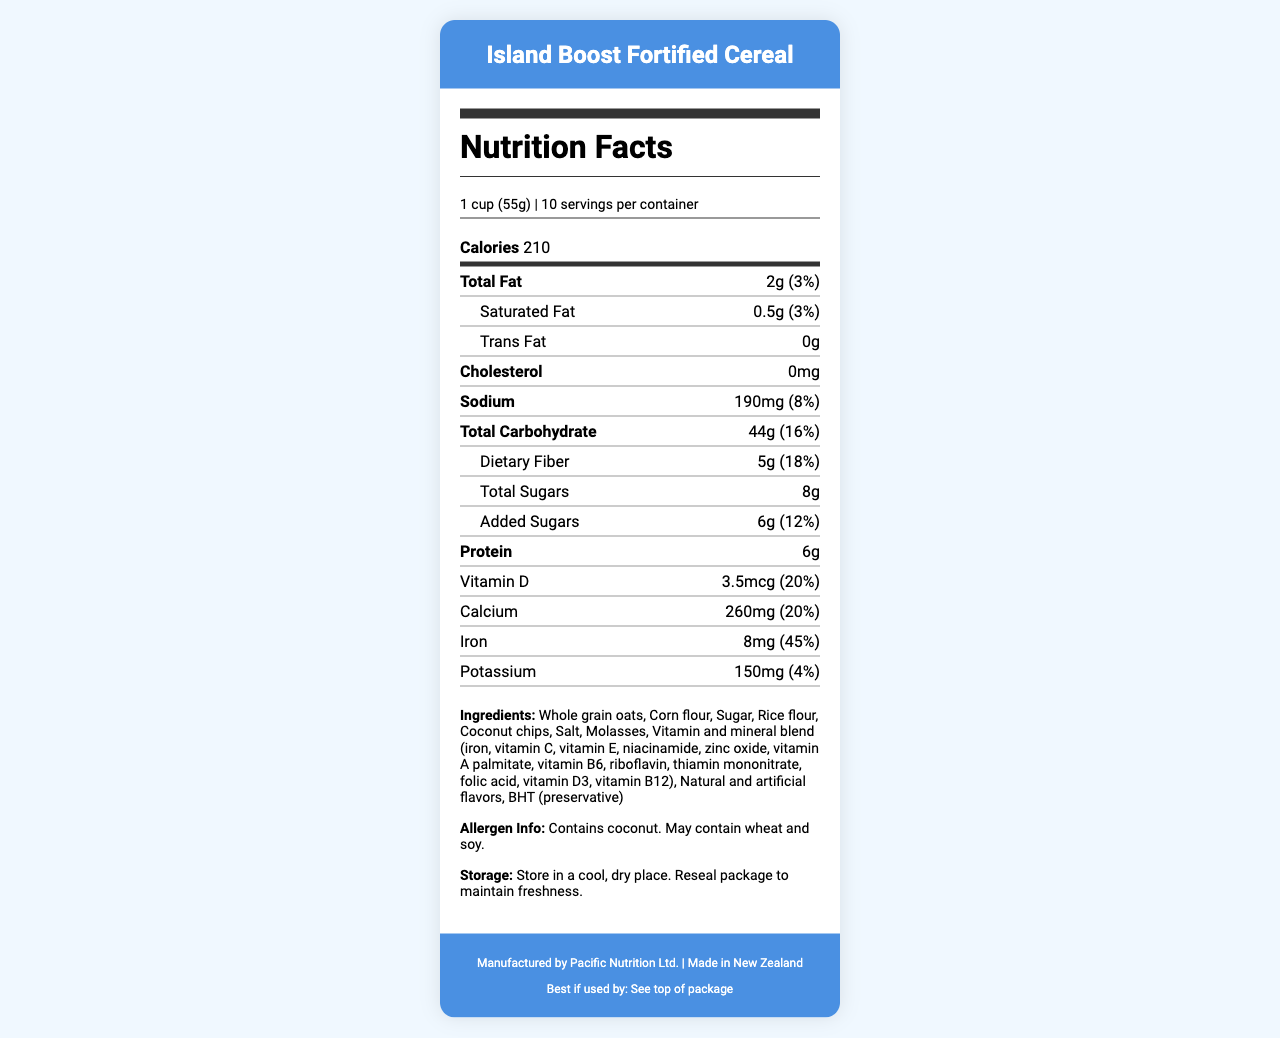What is the serving size of the Island Boost Fortified Cereal? The serving size listed in the document for the Island Boost Fortified Cereal is 1 cup (55g).
Answer: 1 cup (55g) How many servings are there per container? According to the document, there are 10 servings per container.
Answer: 10 How many calories are there per serving? The document states that each serving contains 210 calories.
Answer: 210 What is the total amount of fat per serving? The total fat per serving listed in the document is 2g.
Answer: 2g What percentage of the daily value of iron does one serving provide? The document indicates that one serving provides 45% of the daily value for iron.
Answer: 45% How much Vitamin D does one serving contain? One serving of Island Boost Fortified Cereal contains 3.5mcg of Vitamin D.
Answer: 3.5mcg From which country is the Island Boost Fortified Cereal manufactured? The document specifies that the cereal is made in New Zealand.
Answer: New Zealand What are the added sugars content per serving? The document shows that there are 6g of added sugars per serving.
Answer: 6g Does the cereal contain any saturated fat? The cereal contains 0.5g of saturated fat per serving as mentioned in the document.
Answer: Yes Which of the following vitamins or minerals is present in the highest daily value percentage per serving? A. Vitamin D B. Vitamin B12 C. Zinc D. Vitamin A Vitamin B12 provides the highest daily value percentage at 90% per serving.
Answer: B. Vitamin B12 What is the total amount of dietary fiber in a serving? A. 3g B. 5g C. 7g D. 10g The document indicates that each serving contains 5g of dietary fiber.
Answer: B. 5g How much protein is there per serving? The document lists that there are 6g of protein per serving.
Answer: 6g What is the amount of sodium per serving? According to the document, each serving contains 190mg of sodium.
Answer: 190mg What is the purpose of including Vitamin and mineral blend in the cereal? The blend ensures the cereal is enriched with vitamins and minerals that might be lacking in a typical diet, especially for someone working abroad and possibly not getting a balanced diet.
Answer: It helps fortify the cereal with essential vitamins and minerals to support a balanced diet. Please summarize the document. The document lists detailed facts about the cereal's nutritional content, emphasizing its role in providing essential nutrients. It also includes practical information about ingredients, allergens, storage, and manufacturer details.
Answer: The document provides comprehensive nutritional information about Island Boost Fortified Cereal, including serving size, calories, and amounts of various nutrients and vitamins. It emphasizes the added vitamins and minerals to support a balanced diet, lists the ingredients, mentions allergen information, and provides storage instructions. What is the recommended storage instruction for the cereal? The document advises to store the cereal in a cool, dry place and to reseal the package to maintain freshness.
Answer: Store in a cool, dry place. Reseal package to maintain freshness. Does the Island Boost Fortified Cereal contain any cholesterol? The document states that the cereal contains 0mg of cholesterol.
Answer: No Can you find the exact expiration date of the cereal? The document mentions to see the top of the package for the expiration date, but the exact date is not provided in the visual information.
Answer: Cannot be determined 